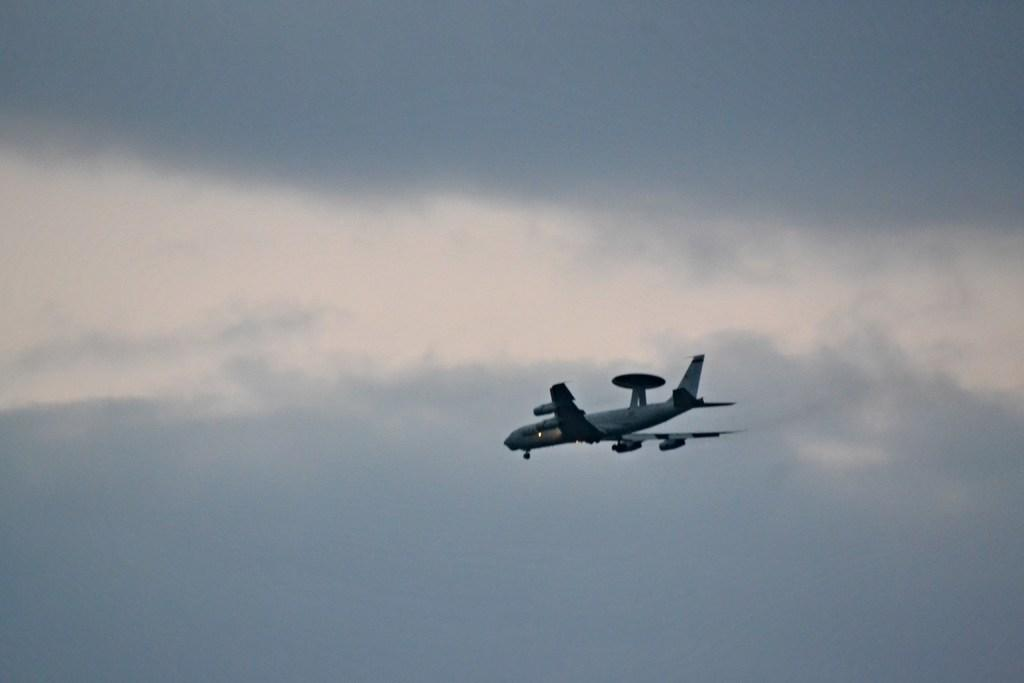What is the main subject of the image? The main subject of the image is an airplane. What is the airplane doing in the image? The airplane is flying in the sky. What can be seen in the background of the image? There are clouds in the background of the image. What is the color of the sky in the image? The sky is blue in color. What type of shirt is the airplane wearing in the image? Airplanes do not wear shirts, as they are inanimate objects. 